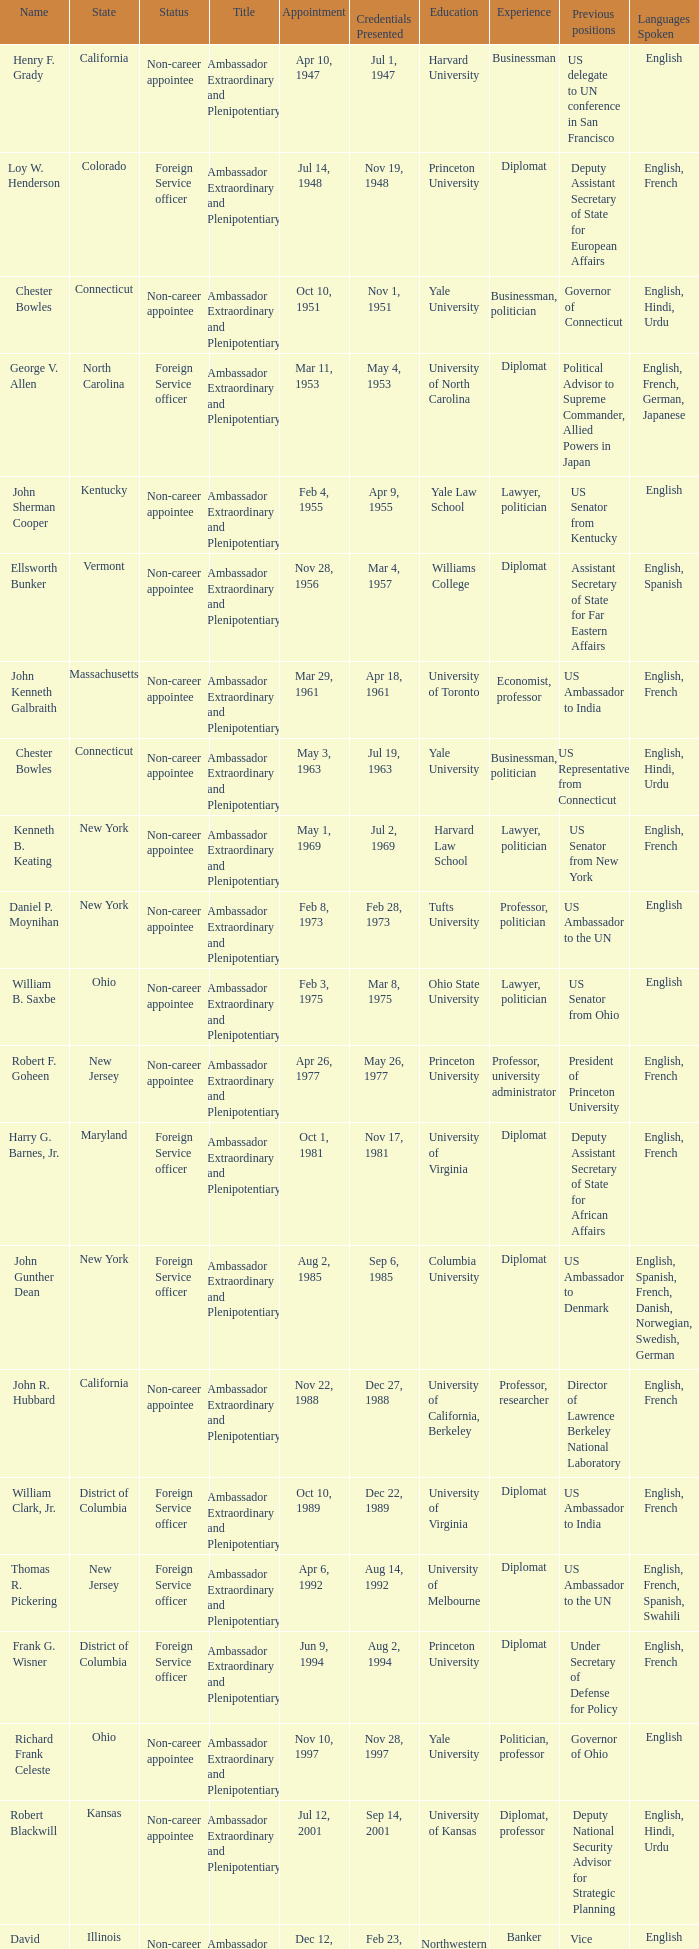What is the title for david campbell mulford? Ambassador Extraordinary and Plenipotentiary. 